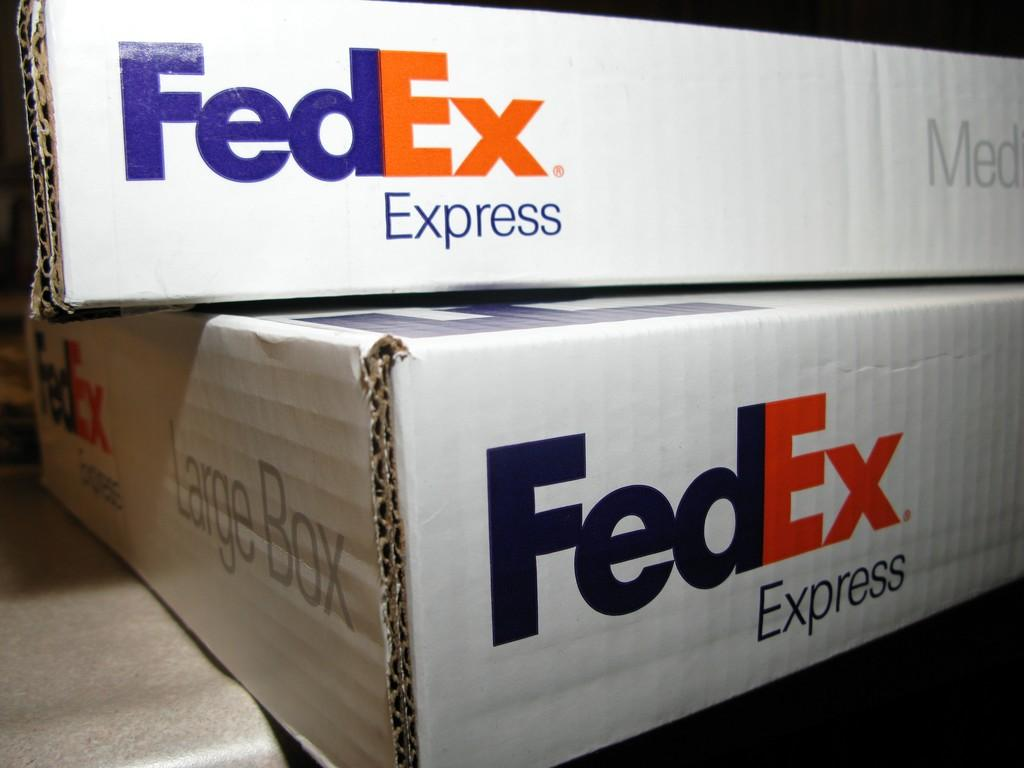<image>
Provide a brief description of the given image. A FedEx Express box on top of another FedEx Express box. 